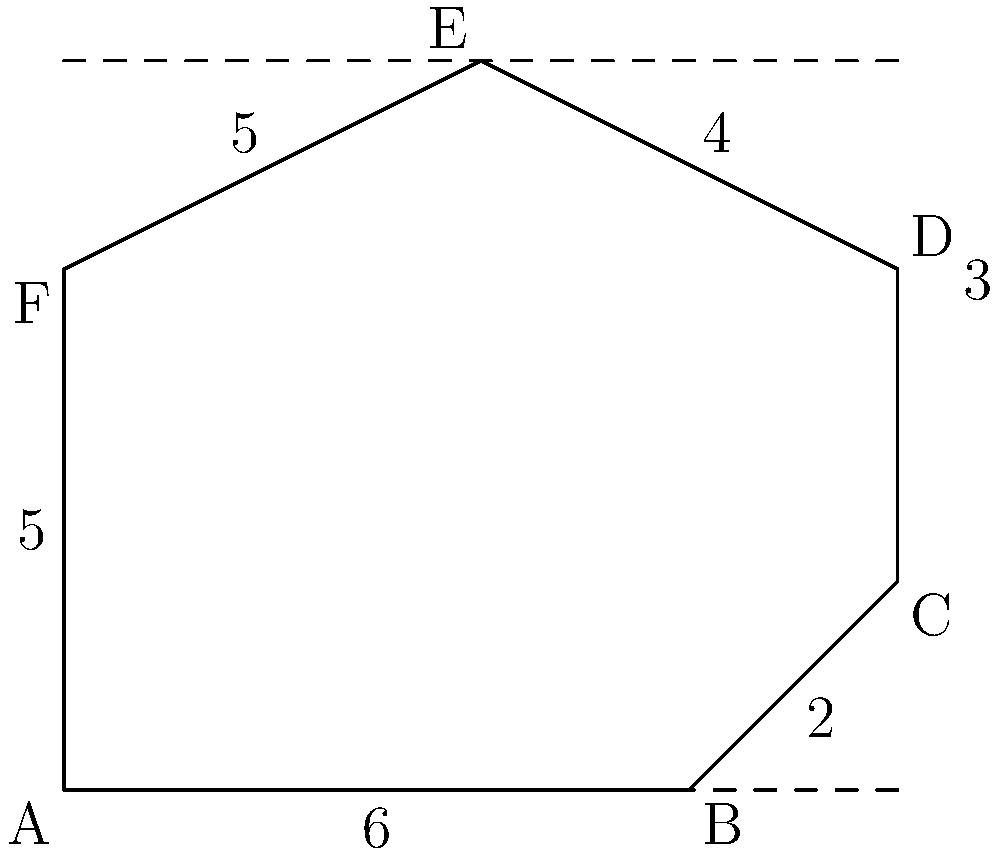In a 1920s urban plan, a city block is represented by the irregular hexagon ABCDEF as shown in the diagram. The dimensions are given in arbitrary units. Calculate the area of this city block. To calculate the area of the irregular hexagon, we can divide it into simpler shapes and sum their areas. Let's approach this step-by-step:

1) Divide the hexagon into a rectangle and two triangles:
   - Rectangle ABDF
   - Triangle BCD
   - Triangle DEF

2) Calculate the area of rectangle ABDF:
   $A_{ABDF} = 6 \times 5 = 30$ square units

3) Calculate the area of triangle BCD:
   Base = 2, Height = 2
   $A_{BCD} = \frac{1}{2} \times 2 \times 2 = 2$ square units

4) Calculate the area of triangle DEF:
   Base = 4, Height = 2
   $A_{DEF} = \frac{1}{2} \times 4 \times 2 = 4$ square units

5) Sum up all the areas:
   $A_{total} = A_{ABDF} + A_{BCD} + A_{DEF}$
   $A_{total} = 30 + 2 + 4 = 36$ square units

Therefore, the total area of the city block is 36 square units.
Answer: 36 square units 